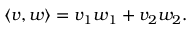<formula> <loc_0><loc_0><loc_500><loc_500>\langle v , w \rangle = v _ { 1 } w _ { 1 } + v _ { 2 } w _ { 2 } .</formula> 